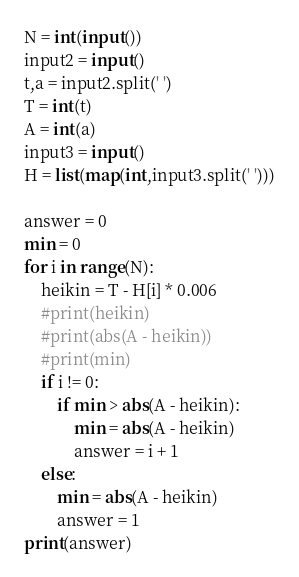Convert code to text. <code><loc_0><loc_0><loc_500><loc_500><_Python_>N = int(input())
input2 = input()
t,a = input2.split(' ')
T = int(t)
A = int(a)
input3 = input()
H = list(map(int,input3.split(' ')))

answer = 0
min = 0
for i in range(N):
    heikin = T - H[i] * 0.006
    #print(heikin)
    #print(abs(A - heikin))
    #print(min)
    if i != 0:
        if min > abs(A - heikin):
            min = abs(A - heikin)
            answer = i + 1
    else:
        min = abs(A - heikin)
        answer = 1
print(answer)
</code> 